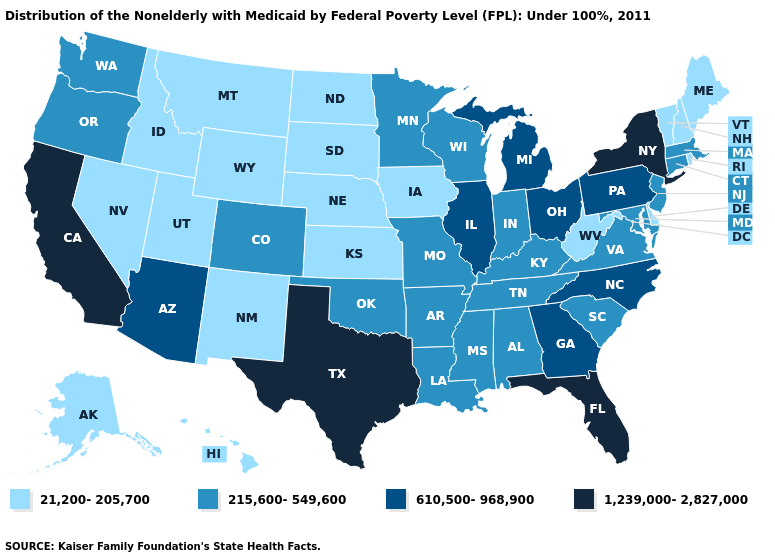Among the states that border Utah , which have the lowest value?
Answer briefly. Idaho, Nevada, New Mexico, Wyoming. Name the states that have a value in the range 215,600-549,600?
Answer briefly. Alabama, Arkansas, Colorado, Connecticut, Indiana, Kentucky, Louisiana, Maryland, Massachusetts, Minnesota, Mississippi, Missouri, New Jersey, Oklahoma, Oregon, South Carolina, Tennessee, Virginia, Washington, Wisconsin. Does Florida have the highest value in the USA?
Short answer required. Yes. Name the states that have a value in the range 215,600-549,600?
Keep it brief. Alabama, Arkansas, Colorado, Connecticut, Indiana, Kentucky, Louisiana, Maryland, Massachusetts, Minnesota, Mississippi, Missouri, New Jersey, Oklahoma, Oregon, South Carolina, Tennessee, Virginia, Washington, Wisconsin. How many symbols are there in the legend?
Quick response, please. 4. What is the value of New Mexico?
Short answer required. 21,200-205,700. Is the legend a continuous bar?
Be succinct. No. Does California have the highest value in the West?
Answer briefly. Yes. Which states have the highest value in the USA?
Write a very short answer. California, Florida, New York, Texas. What is the value of Vermont?
Quick response, please. 21,200-205,700. How many symbols are there in the legend?
Give a very brief answer. 4. What is the lowest value in states that border New Mexico?
Concise answer only. 21,200-205,700. What is the value of Texas?
Concise answer only. 1,239,000-2,827,000. Among the states that border Nebraska , which have the lowest value?
Concise answer only. Iowa, Kansas, South Dakota, Wyoming. Does Texas have a higher value than California?
Concise answer only. No. 